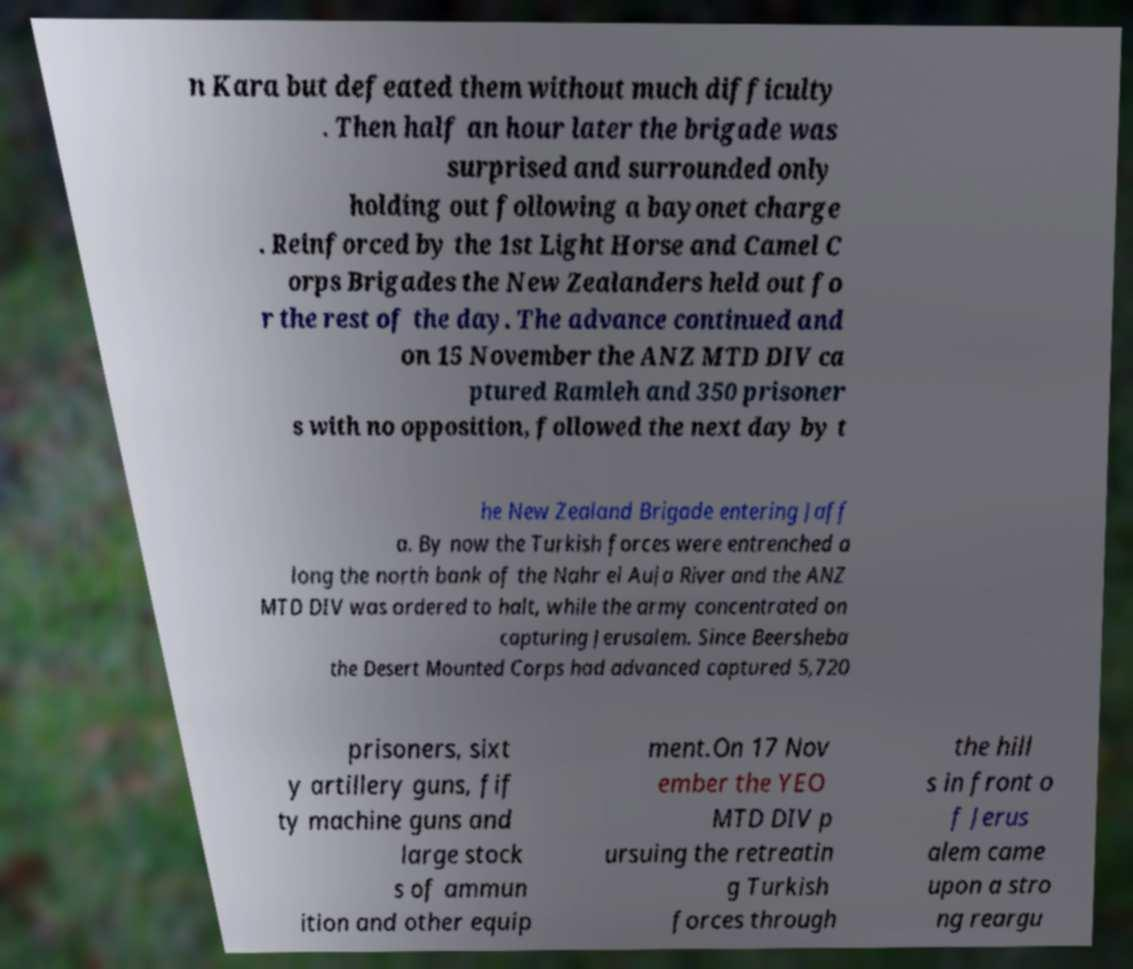I need the written content from this picture converted into text. Can you do that? n Kara but defeated them without much difficulty . Then half an hour later the brigade was surprised and surrounded only holding out following a bayonet charge . Reinforced by the 1st Light Horse and Camel C orps Brigades the New Zealanders held out fo r the rest of the day. The advance continued and on 15 November the ANZ MTD DIV ca ptured Ramleh and 350 prisoner s with no opposition, followed the next day by t he New Zealand Brigade entering Jaff a. By now the Turkish forces were entrenched a long the north bank of the Nahr el Auja River and the ANZ MTD DIV was ordered to halt, while the army concentrated on capturing Jerusalem. Since Beersheba the Desert Mounted Corps had advanced captured 5,720 prisoners, sixt y artillery guns, fif ty machine guns and large stock s of ammun ition and other equip ment.On 17 Nov ember the YEO MTD DIV p ursuing the retreatin g Turkish forces through the hill s in front o f Jerus alem came upon a stro ng reargu 